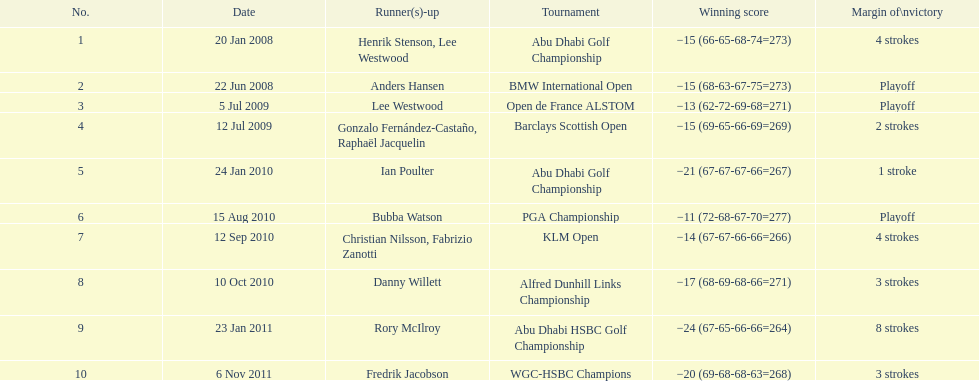How many total tournaments has he won? 10. 